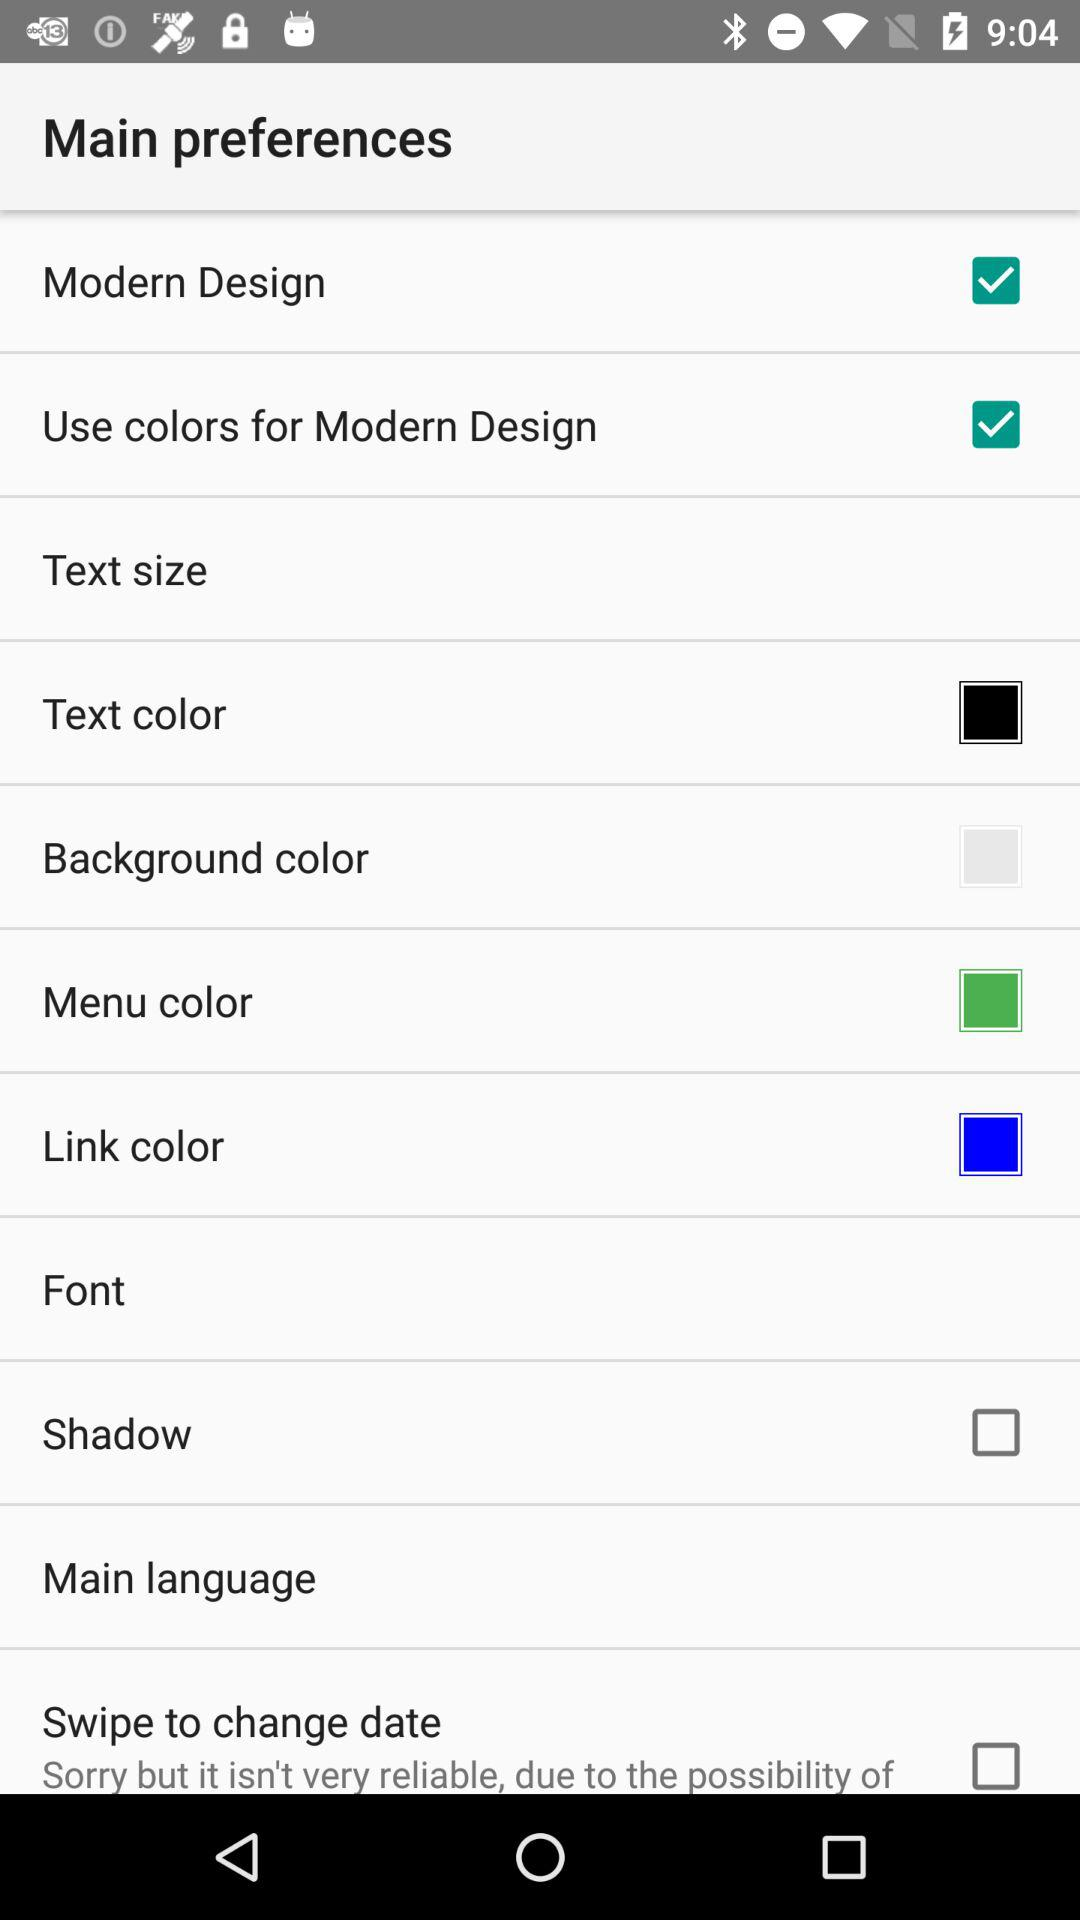What is the menu color?
When the provided information is insufficient, respond with <no answer>. <no answer> 